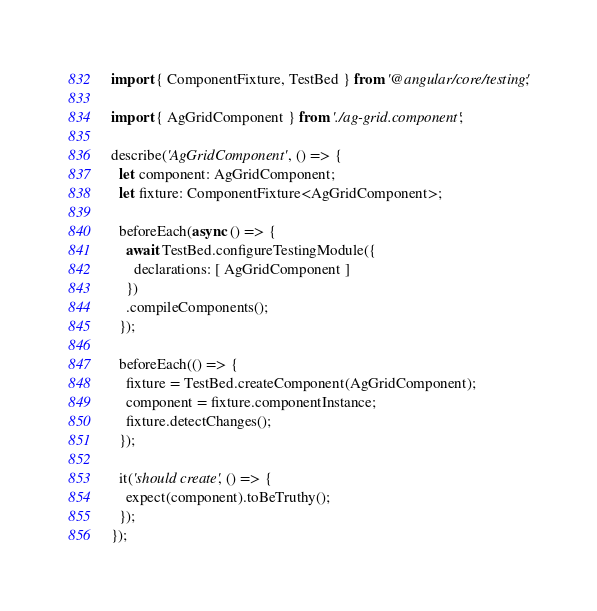<code> <loc_0><loc_0><loc_500><loc_500><_TypeScript_>import { ComponentFixture, TestBed } from '@angular/core/testing';

import { AgGridComponent } from './ag-grid.component';

describe('AgGridComponent', () => {
  let component: AgGridComponent;
  let fixture: ComponentFixture<AgGridComponent>;

  beforeEach(async () => {
    await TestBed.configureTestingModule({
      declarations: [ AgGridComponent ]
    })
    .compileComponents();
  });

  beforeEach(() => {
    fixture = TestBed.createComponent(AgGridComponent);
    component = fixture.componentInstance;
    fixture.detectChanges();
  });

  it('should create', () => {
    expect(component).toBeTruthy();
  });
});
</code> 